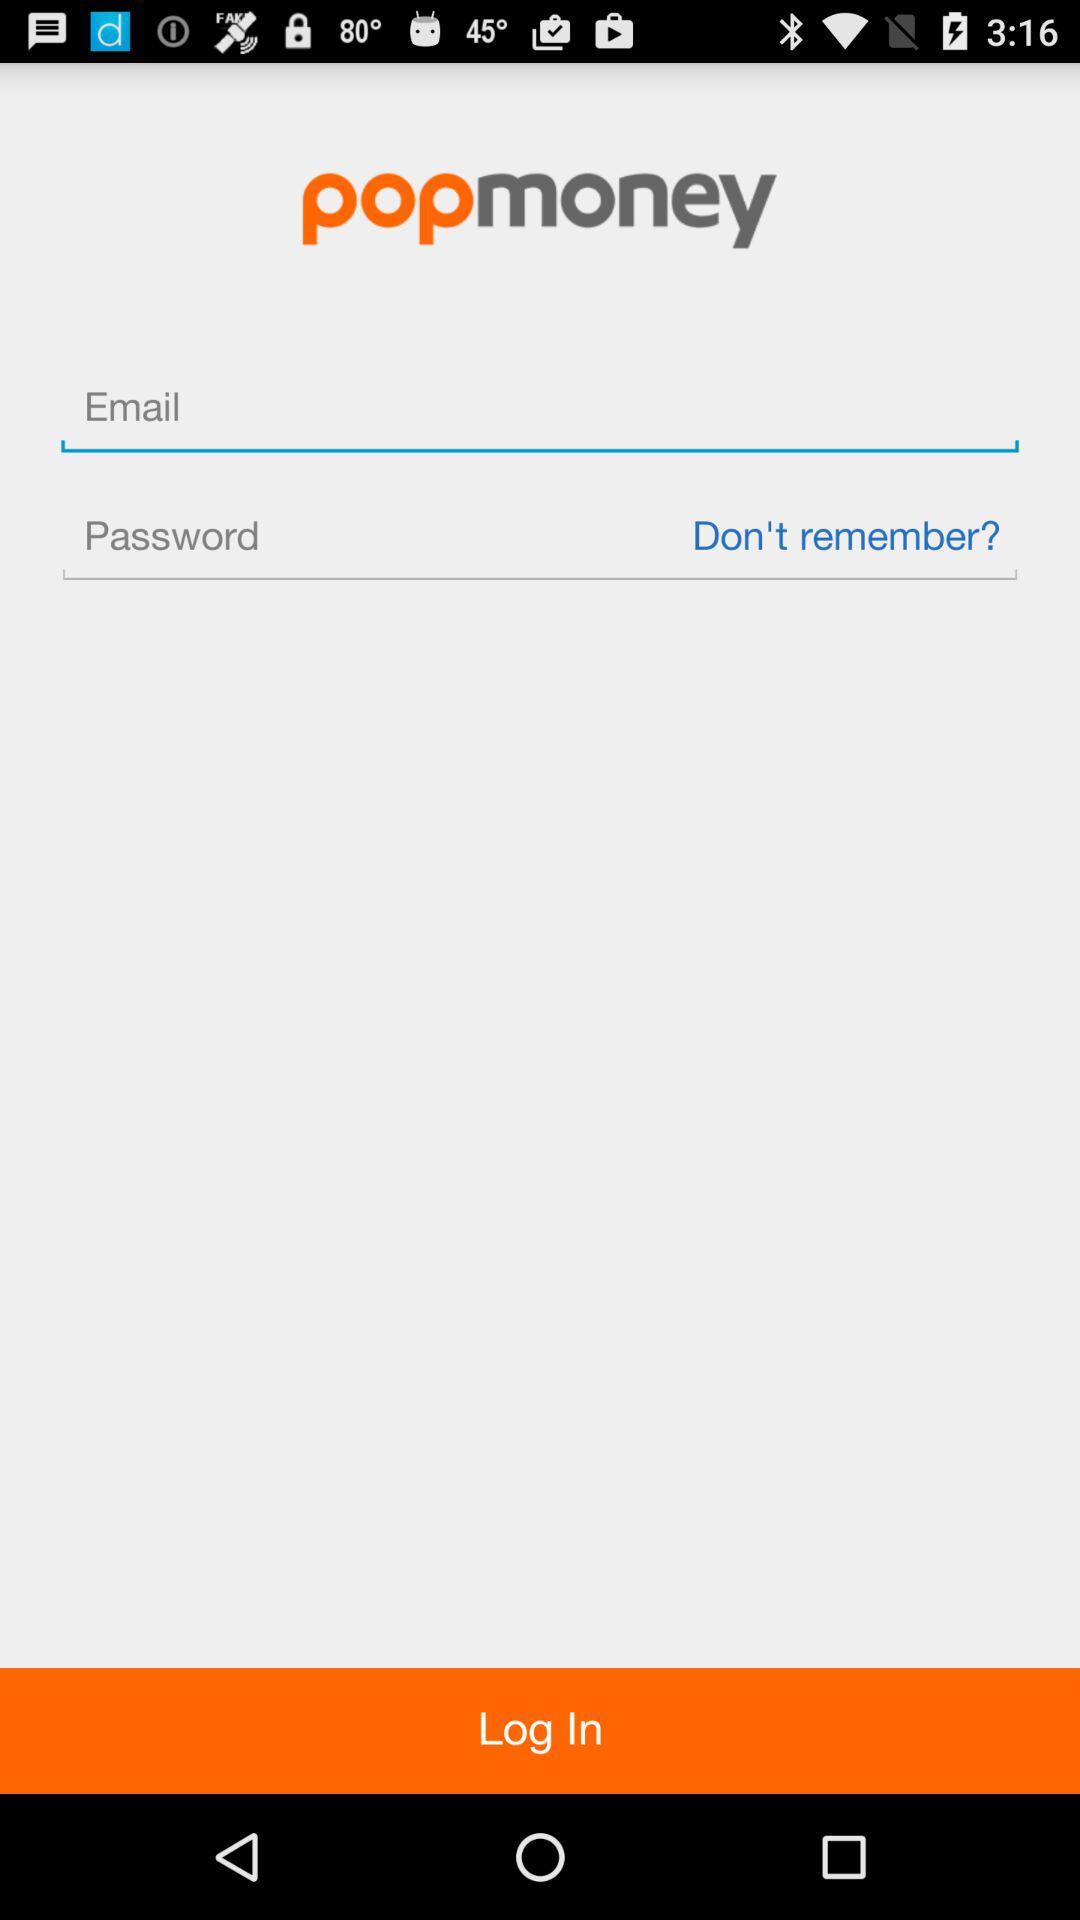What are the requirements to log in? The requirements to log in are email and password. 